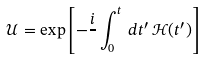Convert formula to latex. <formula><loc_0><loc_0><loc_500><loc_500>\mathcal { U } = \exp \left [ - \frac { i } { } \int _ { 0 } ^ { t } \, d t ^ { \prime } \, \mathcal { H } ( t ^ { \prime } ) \right ]</formula> 